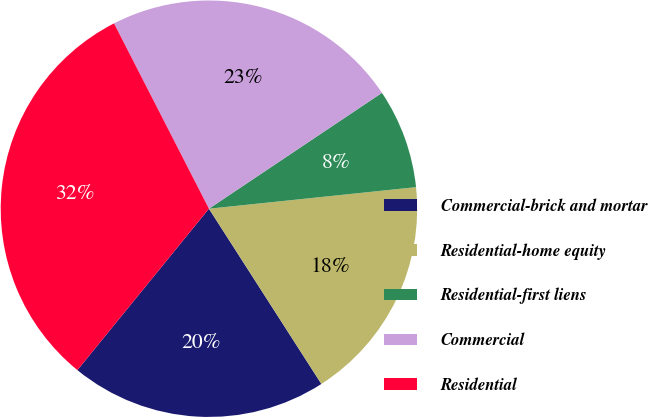Convert chart to OTSL. <chart><loc_0><loc_0><loc_500><loc_500><pie_chart><fcel>Commercial-brick and mortar<fcel>Residential-home equity<fcel>Residential-first liens<fcel>Commercial<fcel>Residential<nl><fcel>19.96%<fcel>17.57%<fcel>7.74%<fcel>23.14%<fcel>31.58%<nl></chart> 